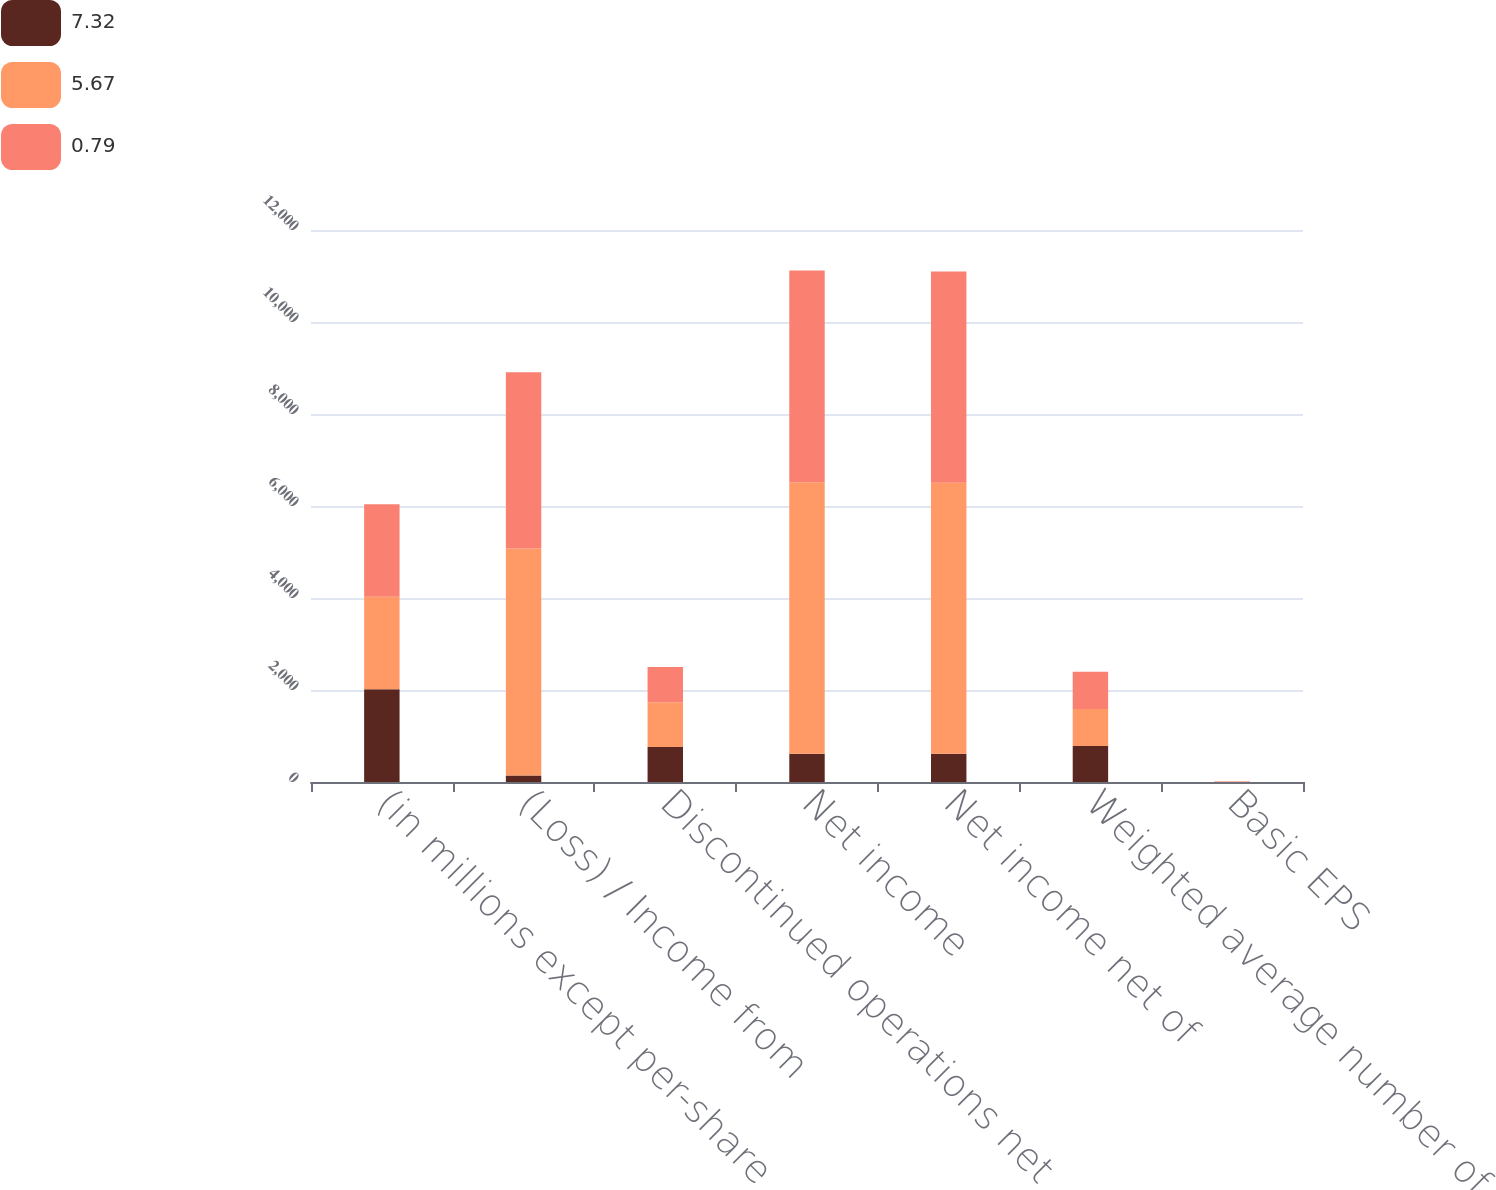Convert chart. <chart><loc_0><loc_0><loc_500><loc_500><stacked_bar_chart><ecel><fcel>(in millions except per-share<fcel>(Loss) / Income from<fcel>Discontinued operations net<fcel>Net income<fcel>Net income net of<fcel>Weighted average number of<fcel>Basic EPS<nl><fcel>7.32<fcel>2014<fcel>144<fcel>760<fcel>616<fcel>616<fcel>781.1<fcel>0.79<nl><fcel>5.67<fcel>2013<fcel>4932<fcel>971<fcel>5903<fcel>5890<fcel>804.1<fcel>7.33<nl><fcel>0.79<fcel>2012<fcel>3829<fcel>769<fcel>4598<fcel>4590<fcel>809.3<fcel>5.67<nl></chart> 